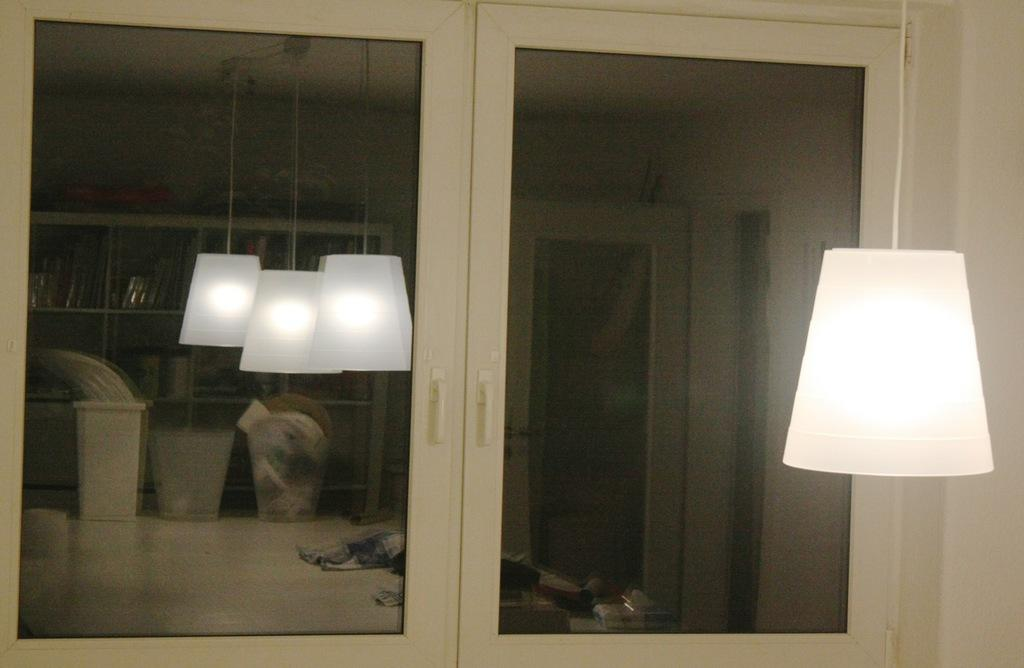What object is hanging on the right side of the image? There is a lamp hanging on the right side of the image. What type of architectural feature is present in the image? There is a glass window in the image. What can be seen in the reflection of the glass window? The reflection of the glass window shows 3 lamps and shelves visible at the back. What is the purpose of the stove in the image? There is no stove present in the image. 